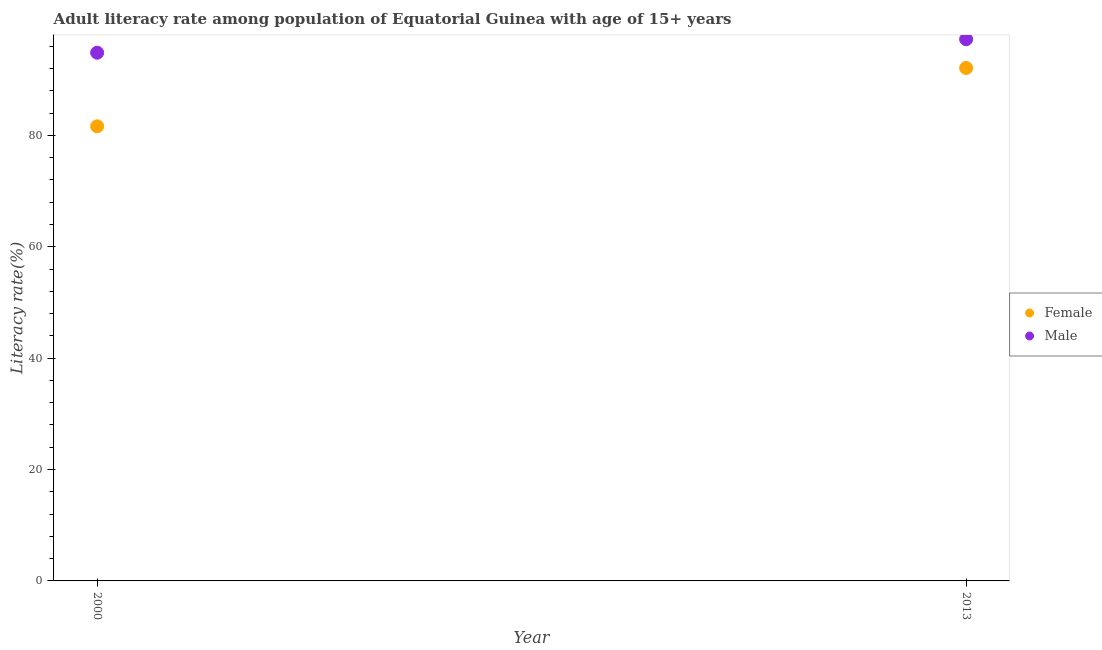How many different coloured dotlines are there?
Offer a terse response. 2. Is the number of dotlines equal to the number of legend labels?
Your response must be concise. Yes. What is the male adult literacy rate in 2013?
Your answer should be compact. 97.26. Across all years, what is the maximum male adult literacy rate?
Offer a terse response. 97.26. Across all years, what is the minimum male adult literacy rate?
Provide a short and direct response. 94.84. In which year was the male adult literacy rate minimum?
Offer a terse response. 2000. What is the total female adult literacy rate in the graph?
Your answer should be very brief. 173.72. What is the difference between the male adult literacy rate in 2000 and that in 2013?
Provide a short and direct response. -2.42. What is the difference between the female adult literacy rate in 2013 and the male adult literacy rate in 2000?
Your answer should be very brief. -2.74. What is the average male adult literacy rate per year?
Provide a short and direct response. 96.05. In the year 2000, what is the difference between the male adult literacy rate and female adult literacy rate?
Offer a terse response. 13.22. In how many years, is the female adult literacy rate greater than 24 %?
Keep it short and to the point. 2. What is the ratio of the female adult literacy rate in 2000 to that in 2013?
Provide a succinct answer. 0.89. Is the female adult literacy rate in 2000 less than that in 2013?
Make the answer very short. Yes. Does the female adult literacy rate monotonically increase over the years?
Make the answer very short. Yes. How many years are there in the graph?
Ensure brevity in your answer.  2. What is the difference between two consecutive major ticks on the Y-axis?
Offer a very short reply. 20. How many legend labels are there?
Offer a terse response. 2. How are the legend labels stacked?
Provide a succinct answer. Vertical. What is the title of the graph?
Your answer should be very brief. Adult literacy rate among population of Equatorial Guinea with age of 15+ years. What is the label or title of the X-axis?
Keep it short and to the point. Year. What is the label or title of the Y-axis?
Provide a succinct answer. Literacy rate(%). What is the Literacy rate(%) in Female in 2000?
Give a very brief answer. 81.62. What is the Literacy rate(%) of Male in 2000?
Provide a short and direct response. 94.84. What is the Literacy rate(%) of Female in 2013?
Give a very brief answer. 92.1. What is the Literacy rate(%) of Male in 2013?
Your answer should be compact. 97.26. Across all years, what is the maximum Literacy rate(%) in Female?
Your answer should be very brief. 92.1. Across all years, what is the maximum Literacy rate(%) in Male?
Your answer should be very brief. 97.26. Across all years, what is the minimum Literacy rate(%) of Female?
Ensure brevity in your answer.  81.62. Across all years, what is the minimum Literacy rate(%) in Male?
Offer a terse response. 94.84. What is the total Literacy rate(%) in Female in the graph?
Ensure brevity in your answer.  173.72. What is the total Literacy rate(%) of Male in the graph?
Give a very brief answer. 192.1. What is the difference between the Literacy rate(%) in Female in 2000 and that in 2013?
Offer a terse response. -10.48. What is the difference between the Literacy rate(%) of Male in 2000 and that in 2013?
Your answer should be compact. -2.42. What is the difference between the Literacy rate(%) in Female in 2000 and the Literacy rate(%) in Male in 2013?
Provide a short and direct response. -15.64. What is the average Literacy rate(%) in Female per year?
Provide a succinct answer. 86.86. What is the average Literacy rate(%) in Male per year?
Offer a terse response. 96.05. In the year 2000, what is the difference between the Literacy rate(%) of Female and Literacy rate(%) of Male?
Offer a very short reply. -13.22. In the year 2013, what is the difference between the Literacy rate(%) of Female and Literacy rate(%) of Male?
Your answer should be very brief. -5.16. What is the ratio of the Literacy rate(%) in Female in 2000 to that in 2013?
Ensure brevity in your answer.  0.89. What is the ratio of the Literacy rate(%) of Male in 2000 to that in 2013?
Offer a terse response. 0.98. What is the difference between the highest and the second highest Literacy rate(%) of Female?
Your answer should be very brief. 10.48. What is the difference between the highest and the second highest Literacy rate(%) in Male?
Keep it short and to the point. 2.42. What is the difference between the highest and the lowest Literacy rate(%) in Female?
Your response must be concise. 10.48. What is the difference between the highest and the lowest Literacy rate(%) in Male?
Your answer should be compact. 2.42. 